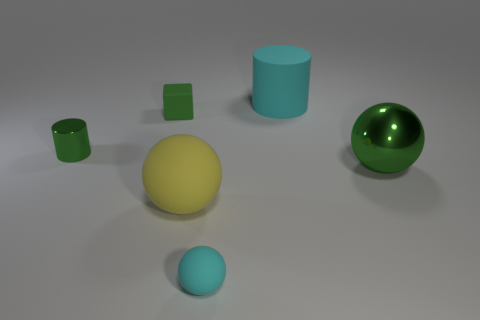What number of metal objects are cyan things or small spheres?
Make the answer very short. 0. What shape is the big cyan object that is made of the same material as the tiny cyan ball?
Keep it short and to the point. Cylinder. What number of things are both behind the yellow sphere and right of the small metal object?
Your response must be concise. 3. Are there any other things that have the same shape as the yellow rubber thing?
Give a very brief answer. Yes. How big is the green metallic object to the right of the tiny green shiny object?
Provide a short and direct response. Large. What number of other things are there of the same color as the rubber cylinder?
Your answer should be very brief. 1. What is the material of the green cylinder behind the large thing that is in front of the green metallic ball?
Offer a very short reply. Metal. Does the rubber block that is left of the rubber cylinder have the same color as the small metallic thing?
Your answer should be very brief. Yes. How many other large objects are the same shape as the big metal thing?
Your answer should be compact. 1. The cylinder that is made of the same material as the yellow thing is what size?
Provide a short and direct response. Large. 